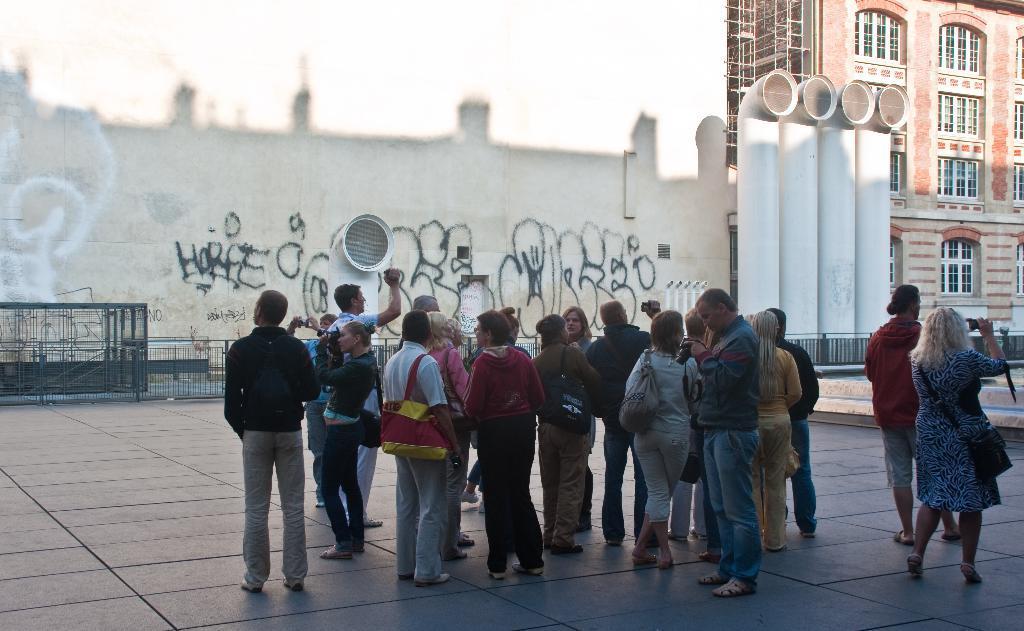Please provide a concise description of this image. In this picture I can see group of people standing, there are iron grilles, there is a building, there are some scribblings on the wall, and these are looking like pipes. 